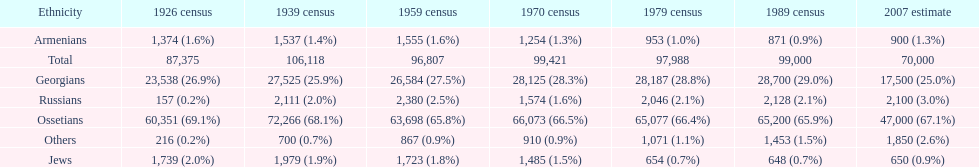How many ethnicity is there? 6. 